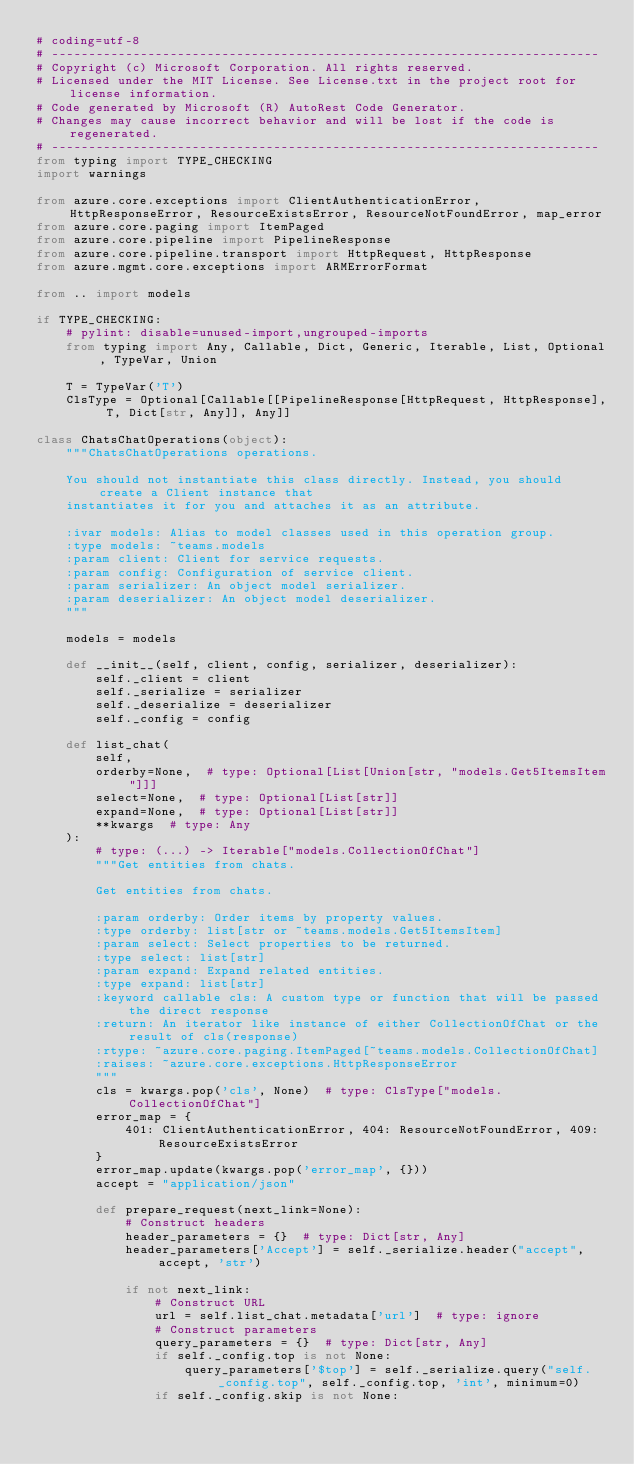Convert code to text. <code><loc_0><loc_0><loc_500><loc_500><_Python_># coding=utf-8
# --------------------------------------------------------------------------
# Copyright (c) Microsoft Corporation. All rights reserved.
# Licensed under the MIT License. See License.txt in the project root for license information.
# Code generated by Microsoft (R) AutoRest Code Generator.
# Changes may cause incorrect behavior and will be lost if the code is regenerated.
# --------------------------------------------------------------------------
from typing import TYPE_CHECKING
import warnings

from azure.core.exceptions import ClientAuthenticationError, HttpResponseError, ResourceExistsError, ResourceNotFoundError, map_error
from azure.core.paging import ItemPaged
from azure.core.pipeline import PipelineResponse
from azure.core.pipeline.transport import HttpRequest, HttpResponse
from azure.mgmt.core.exceptions import ARMErrorFormat

from .. import models

if TYPE_CHECKING:
    # pylint: disable=unused-import,ungrouped-imports
    from typing import Any, Callable, Dict, Generic, Iterable, List, Optional, TypeVar, Union

    T = TypeVar('T')
    ClsType = Optional[Callable[[PipelineResponse[HttpRequest, HttpResponse], T, Dict[str, Any]], Any]]

class ChatsChatOperations(object):
    """ChatsChatOperations operations.

    You should not instantiate this class directly. Instead, you should create a Client instance that
    instantiates it for you and attaches it as an attribute.

    :ivar models: Alias to model classes used in this operation group.
    :type models: ~teams.models
    :param client: Client for service requests.
    :param config: Configuration of service client.
    :param serializer: An object model serializer.
    :param deserializer: An object model deserializer.
    """

    models = models

    def __init__(self, client, config, serializer, deserializer):
        self._client = client
        self._serialize = serializer
        self._deserialize = deserializer
        self._config = config

    def list_chat(
        self,
        orderby=None,  # type: Optional[List[Union[str, "models.Get5ItemsItem"]]]
        select=None,  # type: Optional[List[str]]
        expand=None,  # type: Optional[List[str]]
        **kwargs  # type: Any
    ):
        # type: (...) -> Iterable["models.CollectionOfChat"]
        """Get entities from chats.

        Get entities from chats.

        :param orderby: Order items by property values.
        :type orderby: list[str or ~teams.models.Get5ItemsItem]
        :param select: Select properties to be returned.
        :type select: list[str]
        :param expand: Expand related entities.
        :type expand: list[str]
        :keyword callable cls: A custom type or function that will be passed the direct response
        :return: An iterator like instance of either CollectionOfChat or the result of cls(response)
        :rtype: ~azure.core.paging.ItemPaged[~teams.models.CollectionOfChat]
        :raises: ~azure.core.exceptions.HttpResponseError
        """
        cls = kwargs.pop('cls', None)  # type: ClsType["models.CollectionOfChat"]
        error_map = {
            401: ClientAuthenticationError, 404: ResourceNotFoundError, 409: ResourceExistsError
        }
        error_map.update(kwargs.pop('error_map', {}))
        accept = "application/json"

        def prepare_request(next_link=None):
            # Construct headers
            header_parameters = {}  # type: Dict[str, Any]
            header_parameters['Accept'] = self._serialize.header("accept", accept, 'str')

            if not next_link:
                # Construct URL
                url = self.list_chat.metadata['url']  # type: ignore
                # Construct parameters
                query_parameters = {}  # type: Dict[str, Any]
                if self._config.top is not None:
                    query_parameters['$top'] = self._serialize.query("self._config.top", self._config.top, 'int', minimum=0)
                if self._config.skip is not None:</code> 